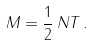<formula> <loc_0><loc_0><loc_500><loc_500>M = \frac { 1 } { 2 } \, N T \, .</formula> 